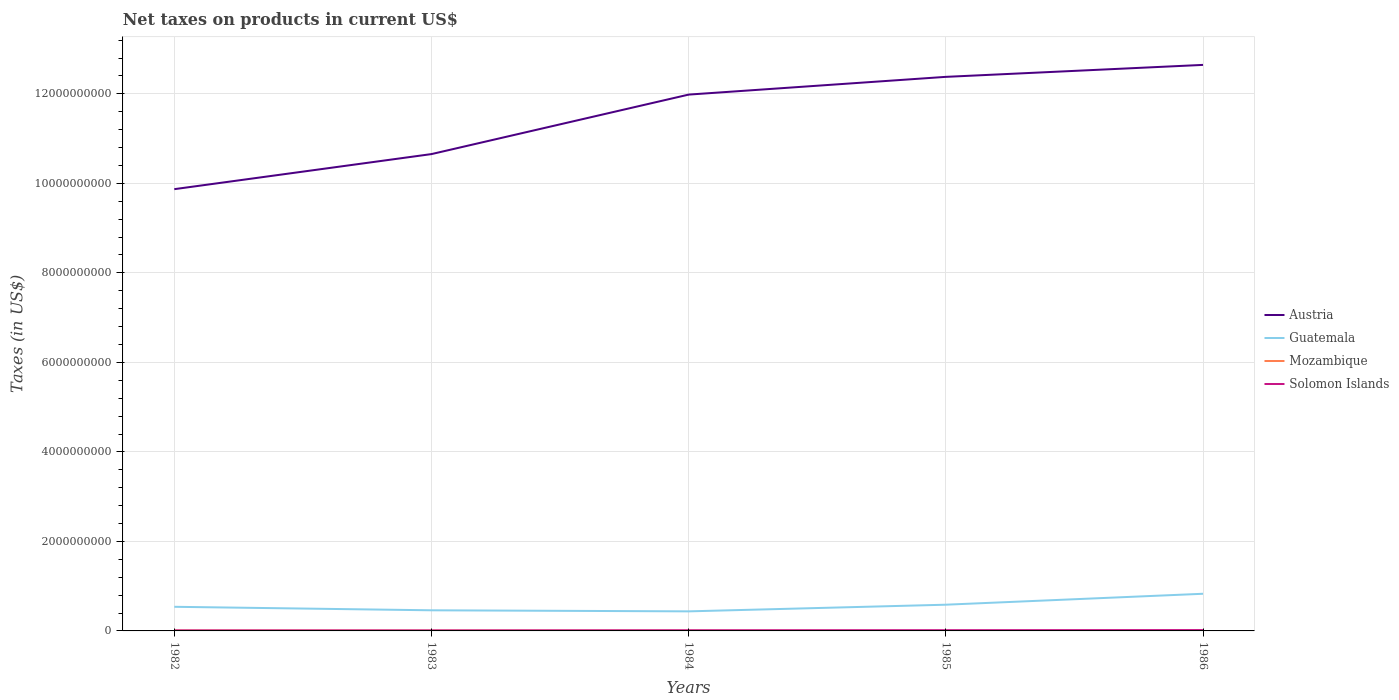How many different coloured lines are there?
Provide a short and direct response. 4. Does the line corresponding to Guatemala intersect with the line corresponding to Solomon Islands?
Your answer should be very brief. No. Is the number of lines equal to the number of legend labels?
Provide a short and direct response. No. Across all years, what is the maximum net taxes on products in Guatemala?
Your response must be concise. 4.37e+08. What is the total net taxes on products in Austria in the graph?
Provide a short and direct response. -6.64e+08. What is the difference between the highest and the second highest net taxes on products in Austria?
Ensure brevity in your answer.  2.78e+09. Is the net taxes on products in Solomon Islands strictly greater than the net taxes on products in Austria over the years?
Provide a short and direct response. Yes. How many years are there in the graph?
Make the answer very short. 5. Are the values on the major ticks of Y-axis written in scientific E-notation?
Provide a short and direct response. No. Does the graph contain grids?
Your answer should be compact. Yes. How are the legend labels stacked?
Your answer should be compact. Vertical. What is the title of the graph?
Provide a succinct answer. Net taxes on products in current US$. Does "Moldova" appear as one of the legend labels in the graph?
Your answer should be compact. No. What is the label or title of the X-axis?
Your response must be concise. Years. What is the label or title of the Y-axis?
Provide a succinct answer. Taxes (in US$). What is the Taxes (in US$) of Austria in 1982?
Provide a succinct answer. 9.87e+09. What is the Taxes (in US$) of Guatemala in 1982?
Provide a short and direct response. 5.39e+08. What is the Taxes (in US$) in Mozambique in 1982?
Keep it short and to the point. 8.50e+06. What is the Taxes (in US$) in Solomon Islands in 1982?
Give a very brief answer. 1.13e+07. What is the Taxes (in US$) of Austria in 1983?
Give a very brief answer. 1.07e+1. What is the Taxes (in US$) in Guatemala in 1983?
Offer a terse response. 4.61e+08. What is the Taxes (in US$) of Mozambique in 1983?
Make the answer very short. 7.20e+06. What is the Taxes (in US$) of Solomon Islands in 1983?
Ensure brevity in your answer.  1.13e+07. What is the Taxes (in US$) in Austria in 1984?
Your answer should be very brief. 1.20e+1. What is the Taxes (in US$) in Guatemala in 1984?
Provide a short and direct response. 4.37e+08. What is the Taxes (in US$) of Mozambique in 1984?
Keep it short and to the point. 5.40e+06. What is the Taxes (in US$) of Solomon Islands in 1984?
Offer a terse response. 1.48e+07. What is the Taxes (in US$) in Austria in 1985?
Your answer should be compact. 1.24e+1. What is the Taxes (in US$) in Guatemala in 1985?
Give a very brief answer. 5.86e+08. What is the Taxes (in US$) of Mozambique in 1985?
Your answer should be very brief. 0. What is the Taxes (in US$) of Solomon Islands in 1985?
Your answer should be very brief. 1.68e+07. What is the Taxes (in US$) of Austria in 1986?
Offer a very short reply. 1.26e+1. What is the Taxes (in US$) in Guatemala in 1986?
Offer a very short reply. 8.30e+08. What is the Taxes (in US$) in Solomon Islands in 1986?
Keep it short and to the point. 1.97e+07. Across all years, what is the maximum Taxes (in US$) in Austria?
Provide a short and direct response. 1.26e+1. Across all years, what is the maximum Taxes (in US$) of Guatemala?
Give a very brief answer. 8.30e+08. Across all years, what is the maximum Taxes (in US$) in Mozambique?
Keep it short and to the point. 8.50e+06. Across all years, what is the maximum Taxes (in US$) of Solomon Islands?
Provide a short and direct response. 1.97e+07. Across all years, what is the minimum Taxes (in US$) of Austria?
Offer a terse response. 9.87e+09. Across all years, what is the minimum Taxes (in US$) of Guatemala?
Ensure brevity in your answer.  4.37e+08. Across all years, what is the minimum Taxes (in US$) in Mozambique?
Provide a short and direct response. 0. Across all years, what is the minimum Taxes (in US$) in Solomon Islands?
Provide a succinct answer. 1.13e+07. What is the total Taxes (in US$) of Austria in the graph?
Make the answer very short. 5.75e+1. What is the total Taxes (in US$) of Guatemala in the graph?
Keep it short and to the point. 2.85e+09. What is the total Taxes (in US$) of Mozambique in the graph?
Provide a succinct answer. 2.11e+07. What is the total Taxes (in US$) of Solomon Islands in the graph?
Ensure brevity in your answer.  7.39e+07. What is the difference between the Taxes (in US$) of Austria in 1982 and that in 1983?
Offer a terse response. -7.84e+08. What is the difference between the Taxes (in US$) in Guatemala in 1982 and that in 1983?
Keep it short and to the point. 7.80e+07. What is the difference between the Taxes (in US$) of Mozambique in 1982 and that in 1983?
Your answer should be compact. 1.30e+06. What is the difference between the Taxes (in US$) in Austria in 1982 and that in 1984?
Offer a very short reply. -2.11e+09. What is the difference between the Taxes (in US$) in Guatemala in 1982 and that in 1984?
Your answer should be compact. 1.02e+08. What is the difference between the Taxes (in US$) in Mozambique in 1982 and that in 1984?
Make the answer very short. 3.10e+06. What is the difference between the Taxes (in US$) in Solomon Islands in 1982 and that in 1984?
Your answer should be compact. -3.50e+06. What is the difference between the Taxes (in US$) in Austria in 1982 and that in 1985?
Provide a short and direct response. -2.51e+09. What is the difference between the Taxes (in US$) in Guatemala in 1982 and that in 1985?
Your answer should be compact. -4.70e+07. What is the difference between the Taxes (in US$) in Solomon Islands in 1982 and that in 1985?
Keep it short and to the point. -5.50e+06. What is the difference between the Taxes (in US$) in Austria in 1982 and that in 1986?
Your response must be concise. -2.78e+09. What is the difference between the Taxes (in US$) in Guatemala in 1982 and that in 1986?
Provide a short and direct response. -2.91e+08. What is the difference between the Taxes (in US$) in Solomon Islands in 1982 and that in 1986?
Ensure brevity in your answer.  -8.40e+06. What is the difference between the Taxes (in US$) of Austria in 1983 and that in 1984?
Give a very brief answer. -1.33e+09. What is the difference between the Taxes (in US$) in Guatemala in 1983 and that in 1984?
Your answer should be compact. 2.40e+07. What is the difference between the Taxes (in US$) in Mozambique in 1983 and that in 1984?
Your answer should be compact. 1.80e+06. What is the difference between the Taxes (in US$) of Solomon Islands in 1983 and that in 1984?
Your answer should be compact. -3.50e+06. What is the difference between the Taxes (in US$) in Austria in 1983 and that in 1985?
Offer a very short reply. -1.73e+09. What is the difference between the Taxes (in US$) in Guatemala in 1983 and that in 1985?
Provide a succinct answer. -1.25e+08. What is the difference between the Taxes (in US$) of Solomon Islands in 1983 and that in 1985?
Offer a very short reply. -5.50e+06. What is the difference between the Taxes (in US$) in Austria in 1983 and that in 1986?
Ensure brevity in your answer.  -1.99e+09. What is the difference between the Taxes (in US$) in Guatemala in 1983 and that in 1986?
Your answer should be very brief. -3.69e+08. What is the difference between the Taxes (in US$) in Solomon Islands in 1983 and that in 1986?
Offer a very short reply. -8.40e+06. What is the difference between the Taxes (in US$) of Austria in 1984 and that in 1985?
Provide a succinct answer. -3.96e+08. What is the difference between the Taxes (in US$) of Guatemala in 1984 and that in 1985?
Ensure brevity in your answer.  -1.49e+08. What is the difference between the Taxes (in US$) of Solomon Islands in 1984 and that in 1985?
Make the answer very short. -2.00e+06. What is the difference between the Taxes (in US$) of Austria in 1984 and that in 1986?
Your answer should be compact. -6.64e+08. What is the difference between the Taxes (in US$) in Guatemala in 1984 and that in 1986?
Provide a short and direct response. -3.93e+08. What is the difference between the Taxes (in US$) of Solomon Islands in 1984 and that in 1986?
Provide a succinct answer. -4.90e+06. What is the difference between the Taxes (in US$) in Austria in 1985 and that in 1986?
Ensure brevity in your answer.  -2.67e+08. What is the difference between the Taxes (in US$) of Guatemala in 1985 and that in 1986?
Ensure brevity in your answer.  -2.44e+08. What is the difference between the Taxes (in US$) of Solomon Islands in 1985 and that in 1986?
Your answer should be compact. -2.90e+06. What is the difference between the Taxes (in US$) of Austria in 1982 and the Taxes (in US$) of Guatemala in 1983?
Your answer should be very brief. 9.41e+09. What is the difference between the Taxes (in US$) of Austria in 1982 and the Taxes (in US$) of Mozambique in 1983?
Your response must be concise. 9.86e+09. What is the difference between the Taxes (in US$) of Austria in 1982 and the Taxes (in US$) of Solomon Islands in 1983?
Make the answer very short. 9.86e+09. What is the difference between the Taxes (in US$) of Guatemala in 1982 and the Taxes (in US$) of Mozambique in 1983?
Your answer should be compact. 5.32e+08. What is the difference between the Taxes (in US$) in Guatemala in 1982 and the Taxes (in US$) in Solomon Islands in 1983?
Keep it short and to the point. 5.28e+08. What is the difference between the Taxes (in US$) of Mozambique in 1982 and the Taxes (in US$) of Solomon Islands in 1983?
Your answer should be very brief. -2.80e+06. What is the difference between the Taxes (in US$) of Austria in 1982 and the Taxes (in US$) of Guatemala in 1984?
Offer a very short reply. 9.43e+09. What is the difference between the Taxes (in US$) of Austria in 1982 and the Taxes (in US$) of Mozambique in 1984?
Make the answer very short. 9.87e+09. What is the difference between the Taxes (in US$) in Austria in 1982 and the Taxes (in US$) in Solomon Islands in 1984?
Offer a terse response. 9.86e+09. What is the difference between the Taxes (in US$) of Guatemala in 1982 and the Taxes (in US$) of Mozambique in 1984?
Your response must be concise. 5.34e+08. What is the difference between the Taxes (in US$) of Guatemala in 1982 and the Taxes (in US$) of Solomon Islands in 1984?
Your response must be concise. 5.24e+08. What is the difference between the Taxes (in US$) in Mozambique in 1982 and the Taxes (in US$) in Solomon Islands in 1984?
Make the answer very short. -6.30e+06. What is the difference between the Taxes (in US$) of Austria in 1982 and the Taxes (in US$) of Guatemala in 1985?
Offer a terse response. 9.29e+09. What is the difference between the Taxes (in US$) in Austria in 1982 and the Taxes (in US$) in Solomon Islands in 1985?
Offer a terse response. 9.85e+09. What is the difference between the Taxes (in US$) of Guatemala in 1982 and the Taxes (in US$) of Solomon Islands in 1985?
Make the answer very short. 5.22e+08. What is the difference between the Taxes (in US$) in Mozambique in 1982 and the Taxes (in US$) in Solomon Islands in 1985?
Give a very brief answer. -8.30e+06. What is the difference between the Taxes (in US$) in Austria in 1982 and the Taxes (in US$) in Guatemala in 1986?
Ensure brevity in your answer.  9.04e+09. What is the difference between the Taxes (in US$) of Austria in 1982 and the Taxes (in US$) of Solomon Islands in 1986?
Provide a succinct answer. 9.85e+09. What is the difference between the Taxes (in US$) in Guatemala in 1982 and the Taxes (in US$) in Solomon Islands in 1986?
Make the answer very short. 5.19e+08. What is the difference between the Taxes (in US$) in Mozambique in 1982 and the Taxes (in US$) in Solomon Islands in 1986?
Provide a succinct answer. -1.12e+07. What is the difference between the Taxes (in US$) in Austria in 1983 and the Taxes (in US$) in Guatemala in 1984?
Ensure brevity in your answer.  1.02e+1. What is the difference between the Taxes (in US$) of Austria in 1983 and the Taxes (in US$) of Mozambique in 1984?
Provide a short and direct response. 1.06e+1. What is the difference between the Taxes (in US$) in Austria in 1983 and the Taxes (in US$) in Solomon Islands in 1984?
Your response must be concise. 1.06e+1. What is the difference between the Taxes (in US$) in Guatemala in 1983 and the Taxes (in US$) in Mozambique in 1984?
Your answer should be very brief. 4.56e+08. What is the difference between the Taxes (in US$) of Guatemala in 1983 and the Taxes (in US$) of Solomon Islands in 1984?
Make the answer very short. 4.46e+08. What is the difference between the Taxes (in US$) in Mozambique in 1983 and the Taxes (in US$) in Solomon Islands in 1984?
Your answer should be compact. -7.60e+06. What is the difference between the Taxes (in US$) in Austria in 1983 and the Taxes (in US$) in Guatemala in 1985?
Provide a succinct answer. 1.01e+1. What is the difference between the Taxes (in US$) in Austria in 1983 and the Taxes (in US$) in Solomon Islands in 1985?
Your answer should be very brief. 1.06e+1. What is the difference between the Taxes (in US$) in Guatemala in 1983 and the Taxes (in US$) in Solomon Islands in 1985?
Your answer should be compact. 4.44e+08. What is the difference between the Taxes (in US$) in Mozambique in 1983 and the Taxes (in US$) in Solomon Islands in 1985?
Your answer should be compact. -9.60e+06. What is the difference between the Taxes (in US$) in Austria in 1983 and the Taxes (in US$) in Guatemala in 1986?
Give a very brief answer. 9.82e+09. What is the difference between the Taxes (in US$) of Austria in 1983 and the Taxes (in US$) of Solomon Islands in 1986?
Offer a terse response. 1.06e+1. What is the difference between the Taxes (in US$) in Guatemala in 1983 and the Taxes (in US$) in Solomon Islands in 1986?
Offer a very short reply. 4.41e+08. What is the difference between the Taxes (in US$) in Mozambique in 1983 and the Taxes (in US$) in Solomon Islands in 1986?
Make the answer very short. -1.25e+07. What is the difference between the Taxes (in US$) in Austria in 1984 and the Taxes (in US$) in Guatemala in 1985?
Ensure brevity in your answer.  1.14e+1. What is the difference between the Taxes (in US$) of Austria in 1984 and the Taxes (in US$) of Solomon Islands in 1985?
Your answer should be compact. 1.20e+1. What is the difference between the Taxes (in US$) of Guatemala in 1984 and the Taxes (in US$) of Solomon Islands in 1985?
Offer a terse response. 4.20e+08. What is the difference between the Taxes (in US$) of Mozambique in 1984 and the Taxes (in US$) of Solomon Islands in 1985?
Your response must be concise. -1.14e+07. What is the difference between the Taxes (in US$) in Austria in 1984 and the Taxes (in US$) in Guatemala in 1986?
Offer a very short reply. 1.12e+1. What is the difference between the Taxes (in US$) in Austria in 1984 and the Taxes (in US$) in Solomon Islands in 1986?
Make the answer very short. 1.20e+1. What is the difference between the Taxes (in US$) of Guatemala in 1984 and the Taxes (in US$) of Solomon Islands in 1986?
Your answer should be very brief. 4.17e+08. What is the difference between the Taxes (in US$) of Mozambique in 1984 and the Taxes (in US$) of Solomon Islands in 1986?
Your response must be concise. -1.43e+07. What is the difference between the Taxes (in US$) of Austria in 1985 and the Taxes (in US$) of Guatemala in 1986?
Provide a short and direct response. 1.16e+1. What is the difference between the Taxes (in US$) in Austria in 1985 and the Taxes (in US$) in Solomon Islands in 1986?
Provide a short and direct response. 1.24e+1. What is the difference between the Taxes (in US$) of Guatemala in 1985 and the Taxes (in US$) of Solomon Islands in 1986?
Ensure brevity in your answer.  5.66e+08. What is the average Taxes (in US$) of Austria per year?
Offer a very short reply. 1.15e+1. What is the average Taxes (in US$) of Guatemala per year?
Provide a succinct answer. 5.71e+08. What is the average Taxes (in US$) in Mozambique per year?
Your answer should be compact. 4.22e+06. What is the average Taxes (in US$) of Solomon Islands per year?
Your answer should be compact. 1.48e+07. In the year 1982, what is the difference between the Taxes (in US$) of Austria and Taxes (in US$) of Guatemala?
Provide a short and direct response. 9.33e+09. In the year 1982, what is the difference between the Taxes (in US$) of Austria and Taxes (in US$) of Mozambique?
Ensure brevity in your answer.  9.86e+09. In the year 1982, what is the difference between the Taxes (in US$) of Austria and Taxes (in US$) of Solomon Islands?
Ensure brevity in your answer.  9.86e+09. In the year 1982, what is the difference between the Taxes (in US$) of Guatemala and Taxes (in US$) of Mozambique?
Your response must be concise. 5.30e+08. In the year 1982, what is the difference between the Taxes (in US$) of Guatemala and Taxes (in US$) of Solomon Islands?
Provide a short and direct response. 5.28e+08. In the year 1982, what is the difference between the Taxes (in US$) of Mozambique and Taxes (in US$) of Solomon Islands?
Make the answer very short. -2.80e+06. In the year 1983, what is the difference between the Taxes (in US$) in Austria and Taxes (in US$) in Guatemala?
Provide a short and direct response. 1.02e+1. In the year 1983, what is the difference between the Taxes (in US$) in Austria and Taxes (in US$) in Mozambique?
Give a very brief answer. 1.06e+1. In the year 1983, what is the difference between the Taxes (in US$) in Austria and Taxes (in US$) in Solomon Islands?
Give a very brief answer. 1.06e+1. In the year 1983, what is the difference between the Taxes (in US$) in Guatemala and Taxes (in US$) in Mozambique?
Your answer should be compact. 4.54e+08. In the year 1983, what is the difference between the Taxes (in US$) of Guatemala and Taxes (in US$) of Solomon Islands?
Provide a short and direct response. 4.50e+08. In the year 1983, what is the difference between the Taxes (in US$) of Mozambique and Taxes (in US$) of Solomon Islands?
Provide a short and direct response. -4.10e+06. In the year 1984, what is the difference between the Taxes (in US$) in Austria and Taxes (in US$) in Guatemala?
Offer a terse response. 1.15e+1. In the year 1984, what is the difference between the Taxes (in US$) in Austria and Taxes (in US$) in Mozambique?
Ensure brevity in your answer.  1.20e+1. In the year 1984, what is the difference between the Taxes (in US$) in Austria and Taxes (in US$) in Solomon Islands?
Keep it short and to the point. 1.20e+1. In the year 1984, what is the difference between the Taxes (in US$) of Guatemala and Taxes (in US$) of Mozambique?
Make the answer very short. 4.32e+08. In the year 1984, what is the difference between the Taxes (in US$) in Guatemala and Taxes (in US$) in Solomon Islands?
Make the answer very short. 4.22e+08. In the year 1984, what is the difference between the Taxes (in US$) in Mozambique and Taxes (in US$) in Solomon Islands?
Provide a succinct answer. -9.40e+06. In the year 1985, what is the difference between the Taxes (in US$) of Austria and Taxes (in US$) of Guatemala?
Provide a succinct answer. 1.18e+1. In the year 1985, what is the difference between the Taxes (in US$) in Austria and Taxes (in US$) in Solomon Islands?
Your response must be concise. 1.24e+1. In the year 1985, what is the difference between the Taxes (in US$) in Guatemala and Taxes (in US$) in Solomon Islands?
Keep it short and to the point. 5.69e+08. In the year 1986, what is the difference between the Taxes (in US$) of Austria and Taxes (in US$) of Guatemala?
Give a very brief answer. 1.18e+1. In the year 1986, what is the difference between the Taxes (in US$) of Austria and Taxes (in US$) of Solomon Islands?
Your response must be concise. 1.26e+1. In the year 1986, what is the difference between the Taxes (in US$) of Guatemala and Taxes (in US$) of Solomon Islands?
Your response must be concise. 8.10e+08. What is the ratio of the Taxes (in US$) in Austria in 1982 to that in 1983?
Your response must be concise. 0.93. What is the ratio of the Taxes (in US$) of Guatemala in 1982 to that in 1983?
Offer a terse response. 1.17. What is the ratio of the Taxes (in US$) of Mozambique in 1982 to that in 1983?
Offer a terse response. 1.18. What is the ratio of the Taxes (in US$) of Solomon Islands in 1982 to that in 1983?
Ensure brevity in your answer.  1. What is the ratio of the Taxes (in US$) of Austria in 1982 to that in 1984?
Provide a succinct answer. 0.82. What is the ratio of the Taxes (in US$) of Guatemala in 1982 to that in 1984?
Your answer should be very brief. 1.23. What is the ratio of the Taxes (in US$) of Mozambique in 1982 to that in 1984?
Your answer should be compact. 1.57. What is the ratio of the Taxes (in US$) of Solomon Islands in 1982 to that in 1984?
Your response must be concise. 0.76. What is the ratio of the Taxes (in US$) in Austria in 1982 to that in 1985?
Your response must be concise. 0.8. What is the ratio of the Taxes (in US$) in Guatemala in 1982 to that in 1985?
Provide a succinct answer. 0.92. What is the ratio of the Taxes (in US$) of Solomon Islands in 1982 to that in 1985?
Make the answer very short. 0.67. What is the ratio of the Taxes (in US$) in Austria in 1982 to that in 1986?
Ensure brevity in your answer.  0.78. What is the ratio of the Taxes (in US$) in Guatemala in 1982 to that in 1986?
Make the answer very short. 0.65. What is the ratio of the Taxes (in US$) of Solomon Islands in 1982 to that in 1986?
Provide a succinct answer. 0.57. What is the ratio of the Taxes (in US$) of Austria in 1983 to that in 1984?
Provide a short and direct response. 0.89. What is the ratio of the Taxes (in US$) of Guatemala in 1983 to that in 1984?
Ensure brevity in your answer.  1.05. What is the ratio of the Taxes (in US$) in Mozambique in 1983 to that in 1984?
Give a very brief answer. 1.33. What is the ratio of the Taxes (in US$) in Solomon Islands in 1983 to that in 1984?
Your answer should be compact. 0.76. What is the ratio of the Taxes (in US$) of Austria in 1983 to that in 1985?
Your answer should be compact. 0.86. What is the ratio of the Taxes (in US$) of Guatemala in 1983 to that in 1985?
Offer a very short reply. 0.79. What is the ratio of the Taxes (in US$) in Solomon Islands in 1983 to that in 1985?
Your answer should be very brief. 0.67. What is the ratio of the Taxes (in US$) of Austria in 1983 to that in 1986?
Your answer should be very brief. 0.84. What is the ratio of the Taxes (in US$) of Guatemala in 1983 to that in 1986?
Offer a very short reply. 0.56. What is the ratio of the Taxes (in US$) of Solomon Islands in 1983 to that in 1986?
Keep it short and to the point. 0.57. What is the ratio of the Taxes (in US$) in Austria in 1984 to that in 1985?
Make the answer very short. 0.97. What is the ratio of the Taxes (in US$) in Guatemala in 1984 to that in 1985?
Your response must be concise. 0.75. What is the ratio of the Taxes (in US$) of Solomon Islands in 1984 to that in 1985?
Make the answer very short. 0.88. What is the ratio of the Taxes (in US$) in Austria in 1984 to that in 1986?
Keep it short and to the point. 0.95. What is the ratio of the Taxes (in US$) in Guatemala in 1984 to that in 1986?
Offer a very short reply. 0.53. What is the ratio of the Taxes (in US$) in Solomon Islands in 1984 to that in 1986?
Provide a short and direct response. 0.75. What is the ratio of the Taxes (in US$) in Austria in 1985 to that in 1986?
Keep it short and to the point. 0.98. What is the ratio of the Taxes (in US$) of Guatemala in 1985 to that in 1986?
Provide a short and direct response. 0.71. What is the ratio of the Taxes (in US$) of Solomon Islands in 1985 to that in 1986?
Offer a very short reply. 0.85. What is the difference between the highest and the second highest Taxes (in US$) in Austria?
Ensure brevity in your answer.  2.67e+08. What is the difference between the highest and the second highest Taxes (in US$) in Guatemala?
Give a very brief answer. 2.44e+08. What is the difference between the highest and the second highest Taxes (in US$) of Mozambique?
Ensure brevity in your answer.  1.30e+06. What is the difference between the highest and the second highest Taxes (in US$) in Solomon Islands?
Ensure brevity in your answer.  2.90e+06. What is the difference between the highest and the lowest Taxes (in US$) in Austria?
Provide a short and direct response. 2.78e+09. What is the difference between the highest and the lowest Taxes (in US$) in Guatemala?
Offer a terse response. 3.93e+08. What is the difference between the highest and the lowest Taxes (in US$) of Mozambique?
Your answer should be very brief. 8.50e+06. What is the difference between the highest and the lowest Taxes (in US$) in Solomon Islands?
Keep it short and to the point. 8.40e+06. 